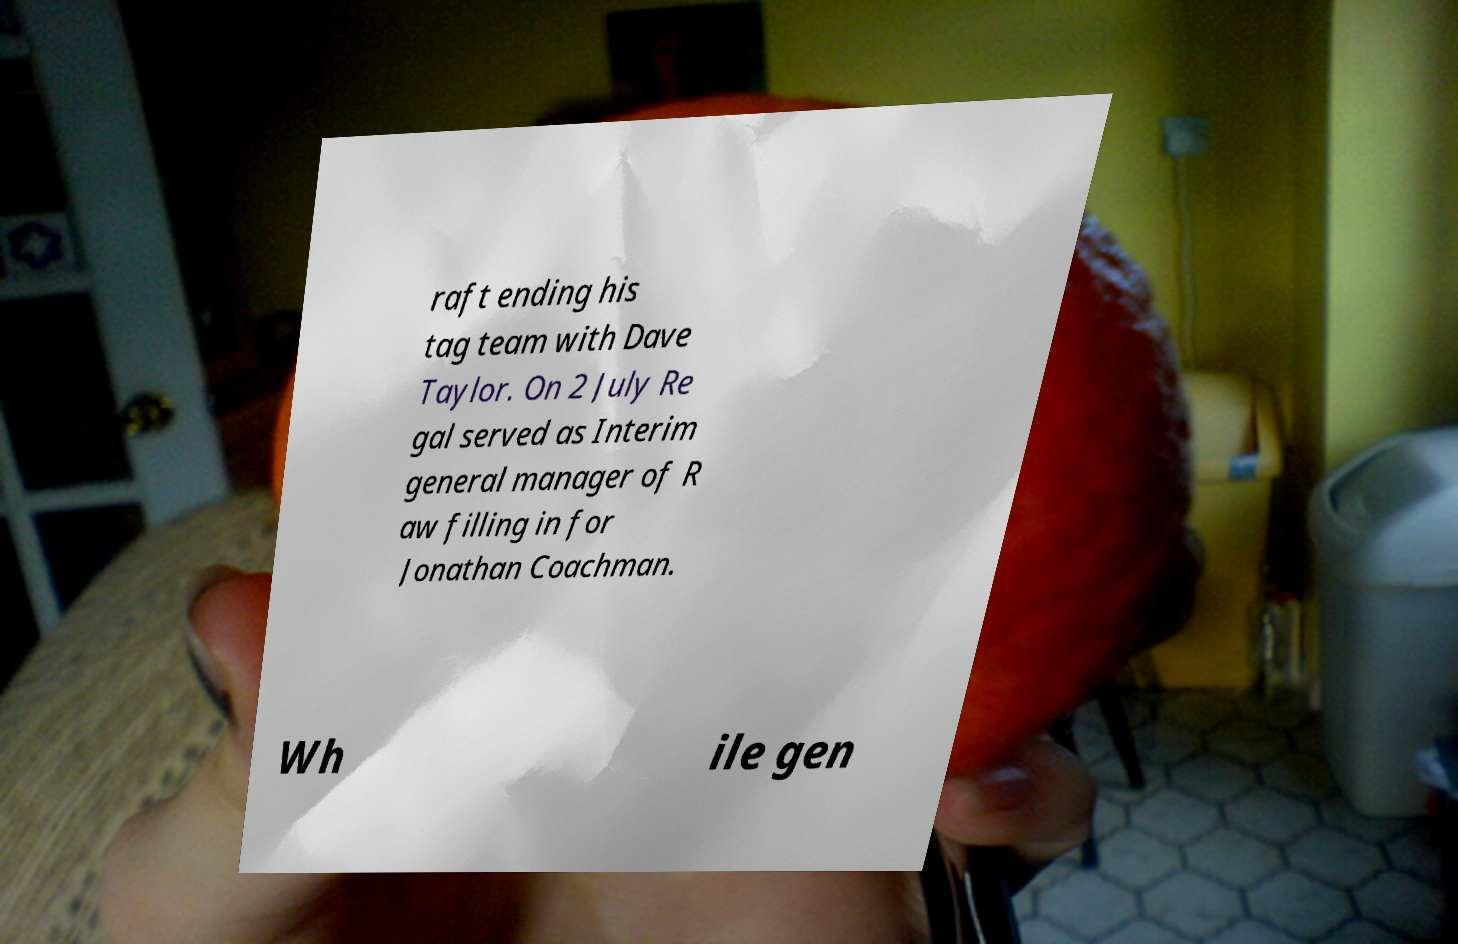Could you extract and type out the text from this image? raft ending his tag team with Dave Taylor. On 2 July Re gal served as Interim general manager of R aw filling in for Jonathan Coachman. Wh ile gen 